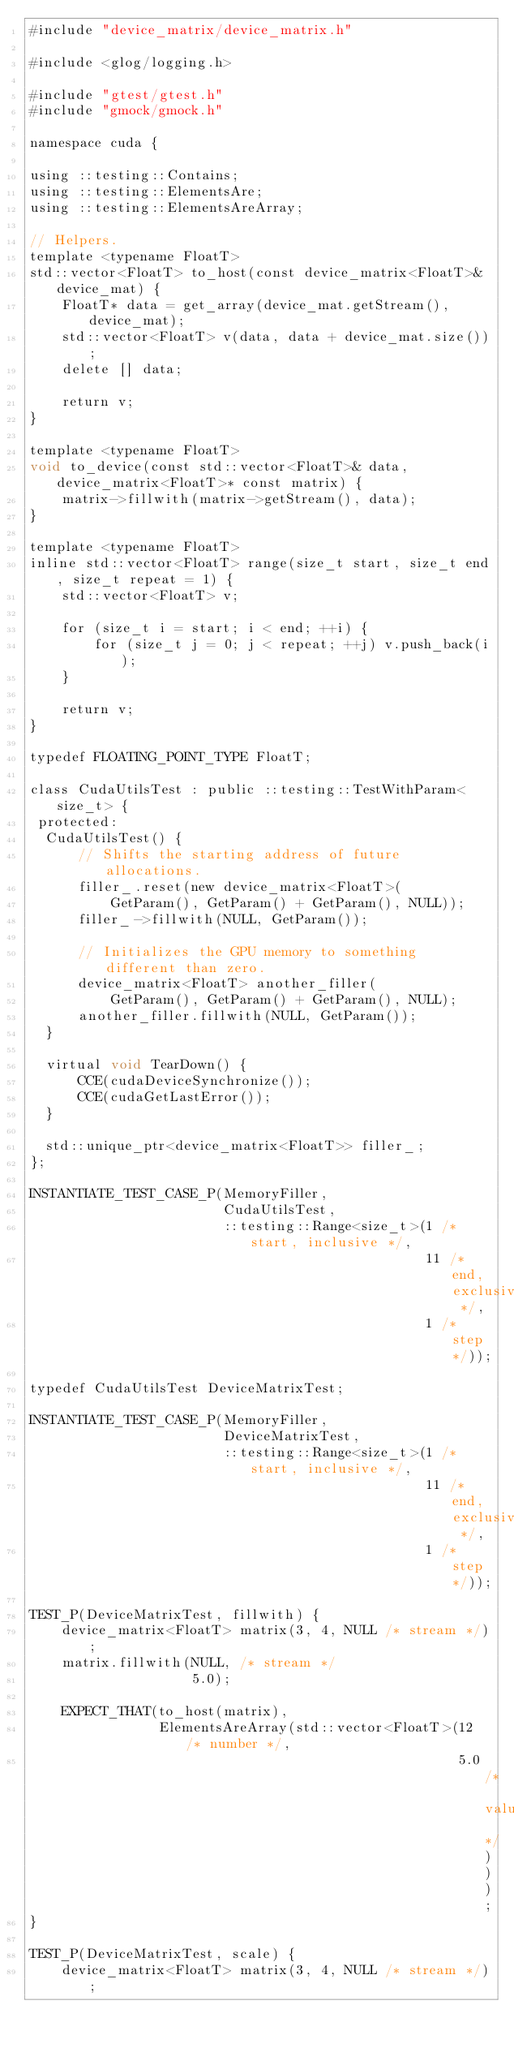<code> <loc_0><loc_0><loc_500><loc_500><_Cuda_>#include "device_matrix/device_matrix.h"

#include <glog/logging.h>

#include "gtest/gtest.h"
#include "gmock/gmock.h"

namespace cuda {

using ::testing::Contains;
using ::testing::ElementsAre;
using ::testing::ElementsAreArray;

// Helpers.
template <typename FloatT>
std::vector<FloatT> to_host(const device_matrix<FloatT>& device_mat) {
    FloatT* data = get_array(device_mat.getStream(), device_mat);
    std::vector<FloatT> v(data, data + device_mat.size());
    delete [] data;

    return v;
}

template <typename FloatT>
void to_device(const std::vector<FloatT>& data, device_matrix<FloatT>* const matrix) {
    matrix->fillwith(matrix->getStream(), data);
}

template <typename FloatT>
inline std::vector<FloatT> range(size_t start, size_t end, size_t repeat = 1) {
    std::vector<FloatT> v;

    for (size_t i = start; i < end; ++i) {
        for (size_t j = 0; j < repeat; ++j) v.push_back(i);
    }

    return v;
}

typedef FLOATING_POINT_TYPE FloatT;

class CudaUtilsTest : public ::testing::TestWithParam<size_t> {
 protected:
  CudaUtilsTest() {
      // Shifts the starting address of future allocations.
      filler_.reset(new device_matrix<FloatT>(
          GetParam(), GetParam() + GetParam(), NULL));
      filler_->fillwith(NULL, GetParam());

      // Initializes the GPU memory to something different than zero.
      device_matrix<FloatT> another_filler(
          GetParam(), GetParam() + GetParam(), NULL);
      another_filler.fillwith(NULL, GetParam());
  }

  virtual void TearDown() {
      CCE(cudaDeviceSynchronize());
      CCE(cudaGetLastError());
  }

  std::unique_ptr<device_matrix<FloatT>> filler_;
};

INSTANTIATE_TEST_CASE_P(MemoryFiller,
                        CudaUtilsTest,
                        ::testing::Range<size_t>(1 /* start, inclusive */,
                                                 11 /* end, exclusive */,
                                                 1 /* step */));

typedef CudaUtilsTest DeviceMatrixTest;

INSTANTIATE_TEST_CASE_P(MemoryFiller,
                        DeviceMatrixTest,
                        ::testing::Range<size_t>(1 /* start, inclusive */,
                                                 11 /* end, exclusive */,
                                                 1 /* step */));

TEST_P(DeviceMatrixTest, fillwith) {
    device_matrix<FloatT> matrix(3, 4, NULL /* stream */);
    matrix.fillwith(NULL, /* stream */
                    5.0);

    EXPECT_THAT(to_host(matrix),
                ElementsAreArray(std::vector<FloatT>(12 /* number */,
                                                     5.0 /* value */)));
}

TEST_P(DeviceMatrixTest, scale) {
    device_matrix<FloatT> matrix(3, 4, NULL /* stream */);</code> 